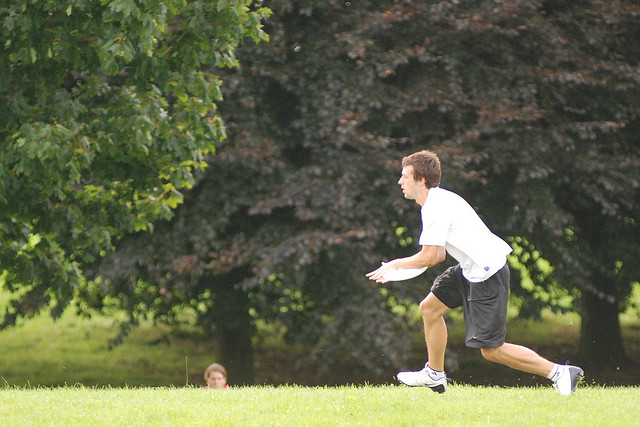Describe the setting of this image. The setting of the image is a tranquil park or recreational area, with well-maintained grass, trees providing abundant foliage, and a serene atmosphere. It seems to be a pleasant day with ample sunlight, likely conducive to outdoor activities and relaxation. 